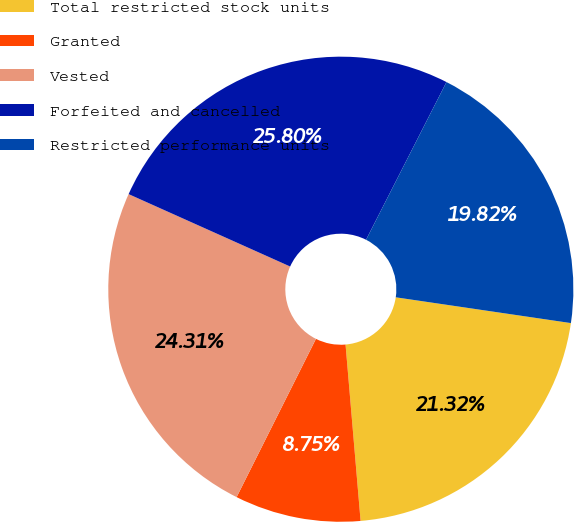<chart> <loc_0><loc_0><loc_500><loc_500><pie_chart><fcel>Total restricted stock units<fcel>Granted<fcel>Vested<fcel>Forfeited and cancelled<fcel>Restricted performance units<nl><fcel>21.32%<fcel>8.75%<fcel>24.31%<fcel>25.8%<fcel>19.82%<nl></chart> 